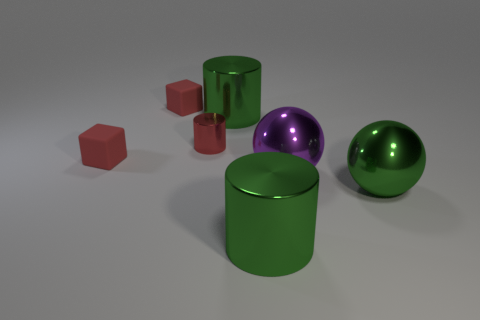How many things are either small things behind the tiny red cylinder or shiny objects that are on the right side of the tiny red shiny cylinder?
Offer a terse response. 5. There is another big thing that is the same shape as the large purple shiny object; what is its material?
Your answer should be compact. Metal. How many objects are tiny red rubber objects that are in front of the small cylinder or large green metallic objects?
Your answer should be compact. 4. What is the shape of the small red thing that is the same material as the large purple sphere?
Your answer should be compact. Cylinder. How many other big objects are the same shape as the purple thing?
Your answer should be compact. 1. What material is the purple ball?
Make the answer very short. Metal. Does the small shiny object have the same color as the large thing that is in front of the green shiny ball?
Provide a short and direct response. No. How many balls are big green metallic objects or red things?
Ensure brevity in your answer.  1. What is the color of the ball to the left of the big green ball?
Make the answer very short. Purple. What number of matte things are the same size as the red shiny object?
Your response must be concise. 2. 